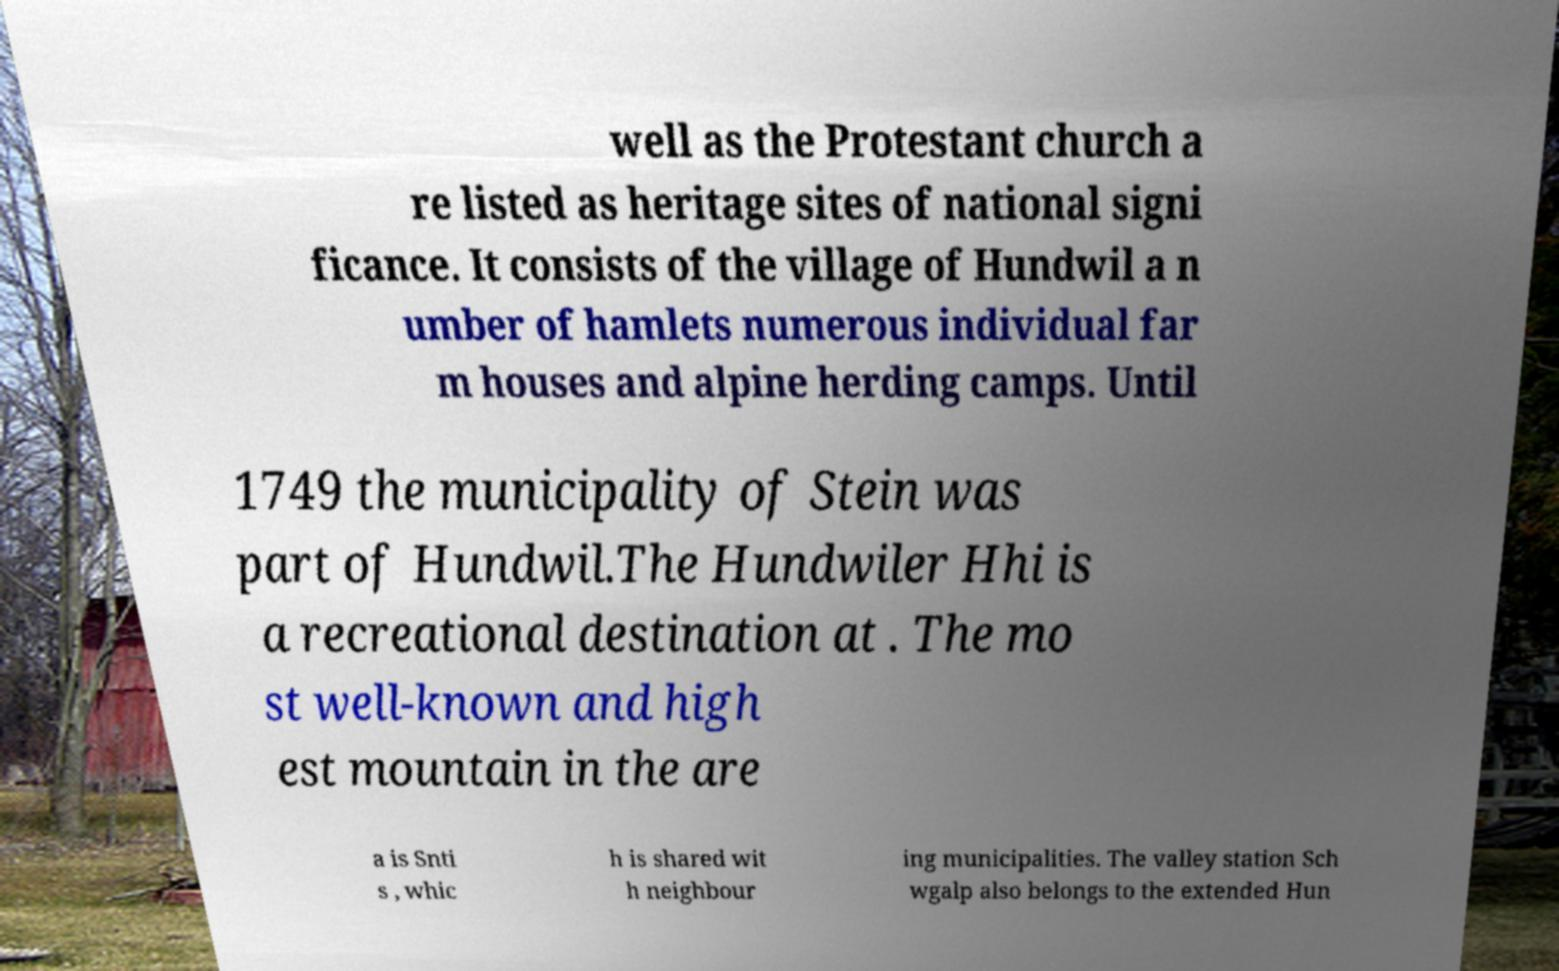There's text embedded in this image that I need extracted. Can you transcribe it verbatim? well as the Protestant church a re listed as heritage sites of national signi ficance. It consists of the village of Hundwil a n umber of hamlets numerous individual far m houses and alpine herding camps. Until 1749 the municipality of Stein was part of Hundwil.The Hundwiler Hhi is a recreational destination at . The mo st well-known and high est mountain in the are a is Snti s , whic h is shared wit h neighbour ing municipalities. The valley station Sch wgalp also belongs to the extended Hun 